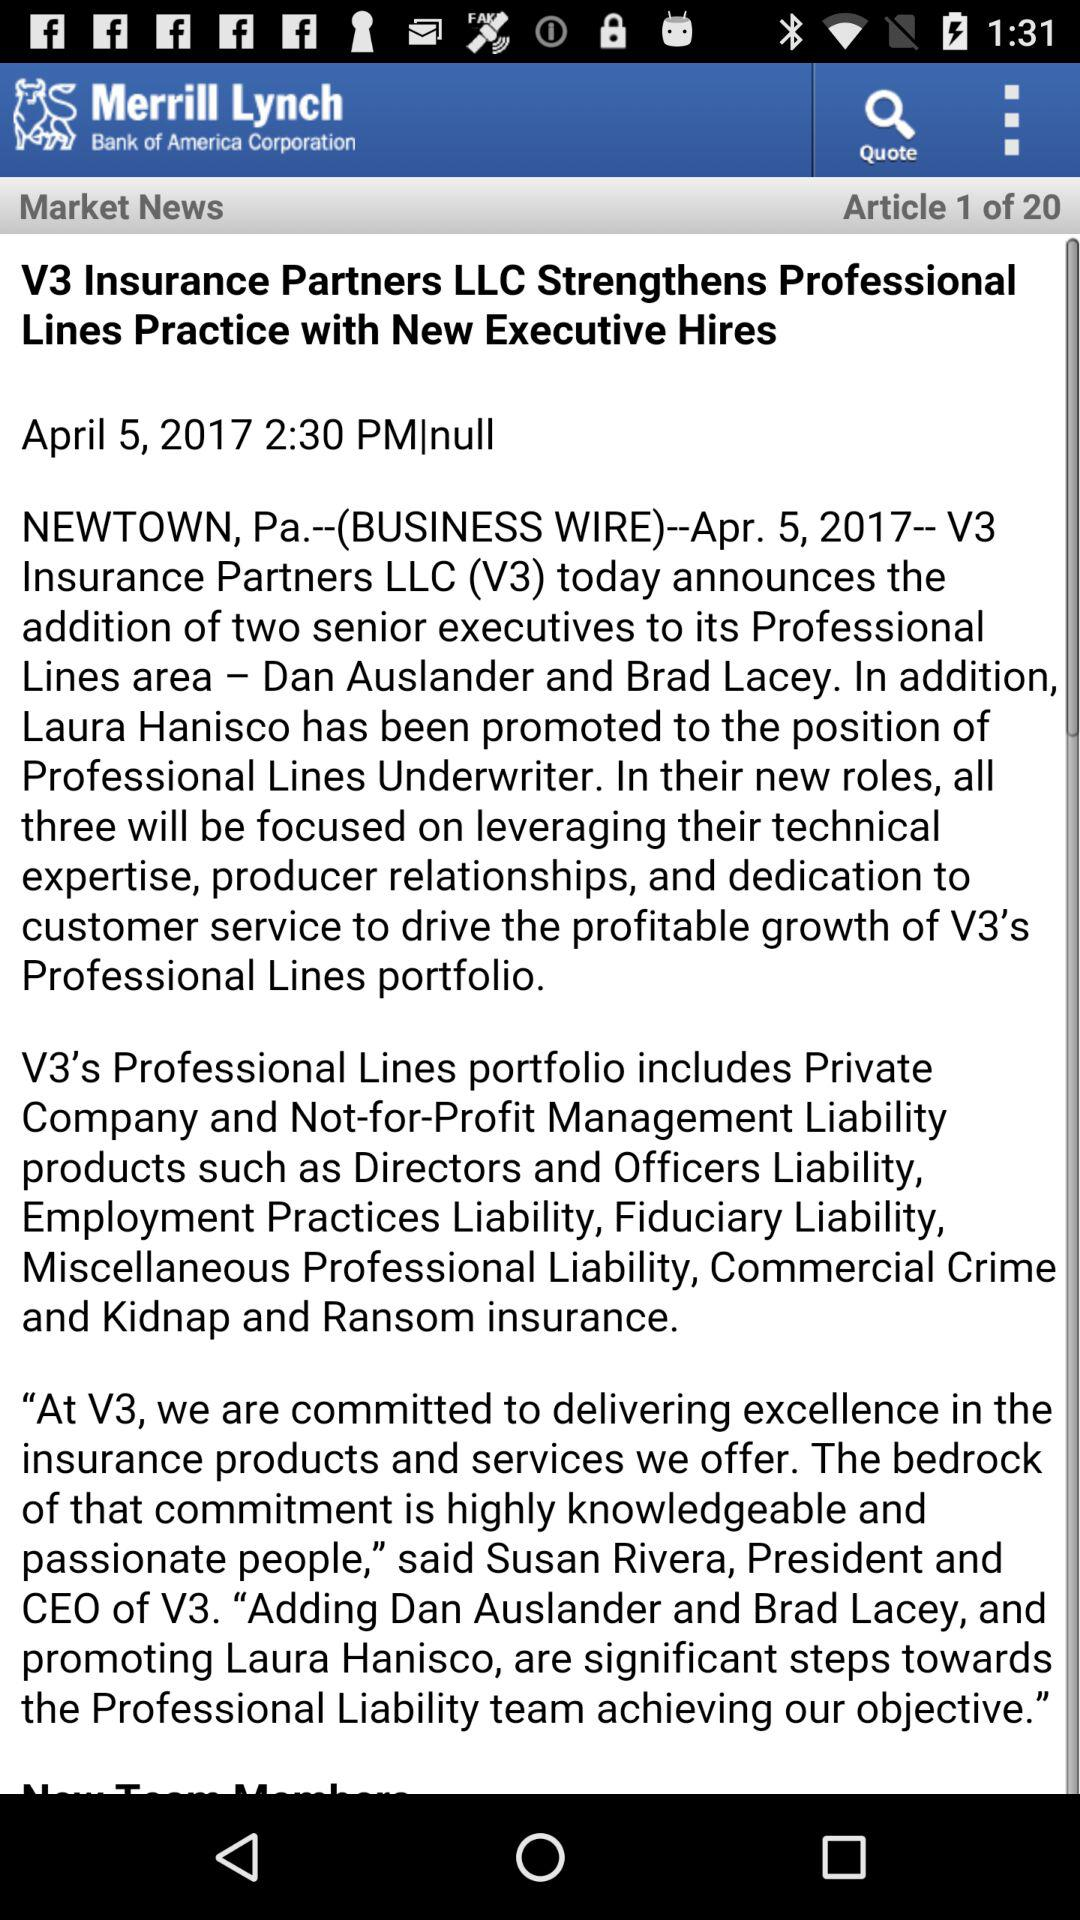What is the date and time? The date and time is April 5, 2017 at 2:30 PM. 